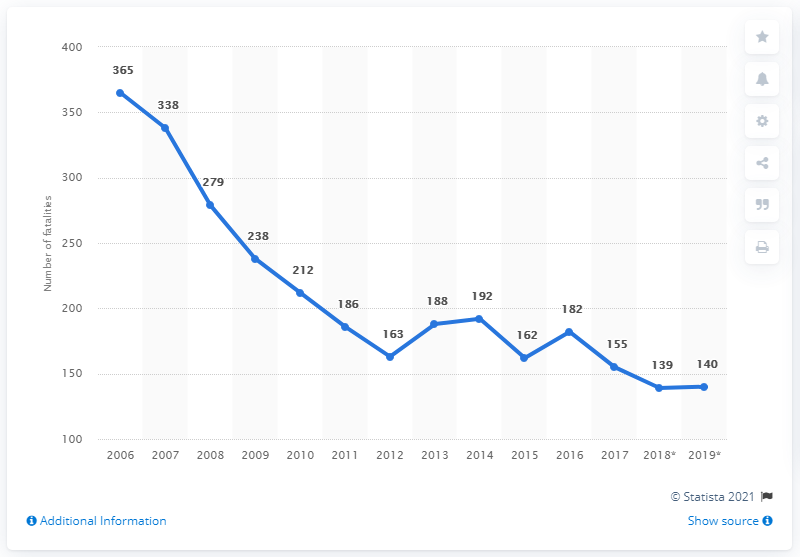Mention a couple of crucial points in this snapshot. There were 365 road fatalities in Ireland between 2006 and 2019. In 2019, the reported number of road traffic fatalities in Ireland was 140. 